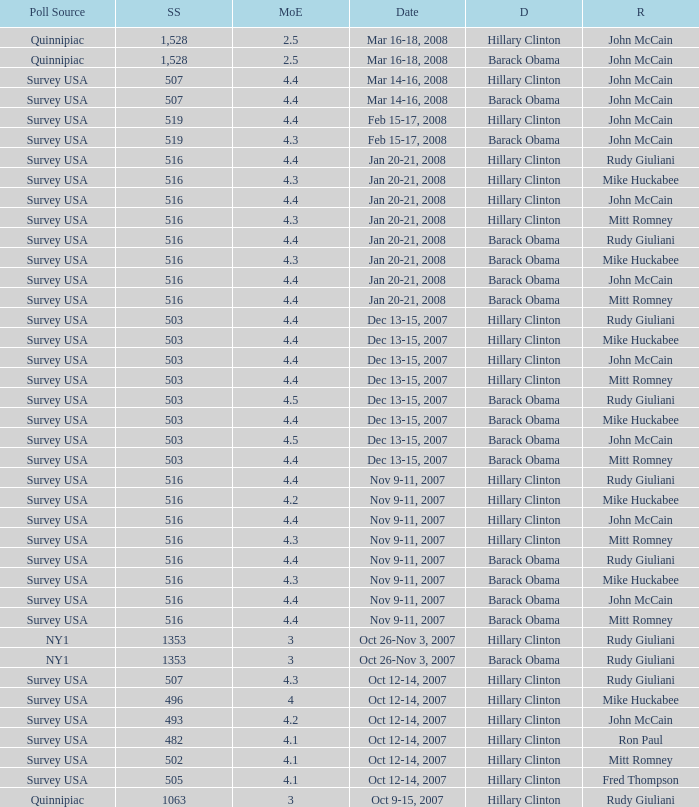Which Democrat was selected in the poll with a sample size smaller than 516 where the Republican chosen was Ron Paul? Hillary Clinton. 